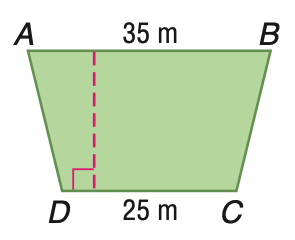Question: Trapezoid A B C D has an area of 750 square meters. Find the height of A B C D.
Choices:
A. 20
B. 25
C. 30
D. 35
Answer with the letter. Answer: B 